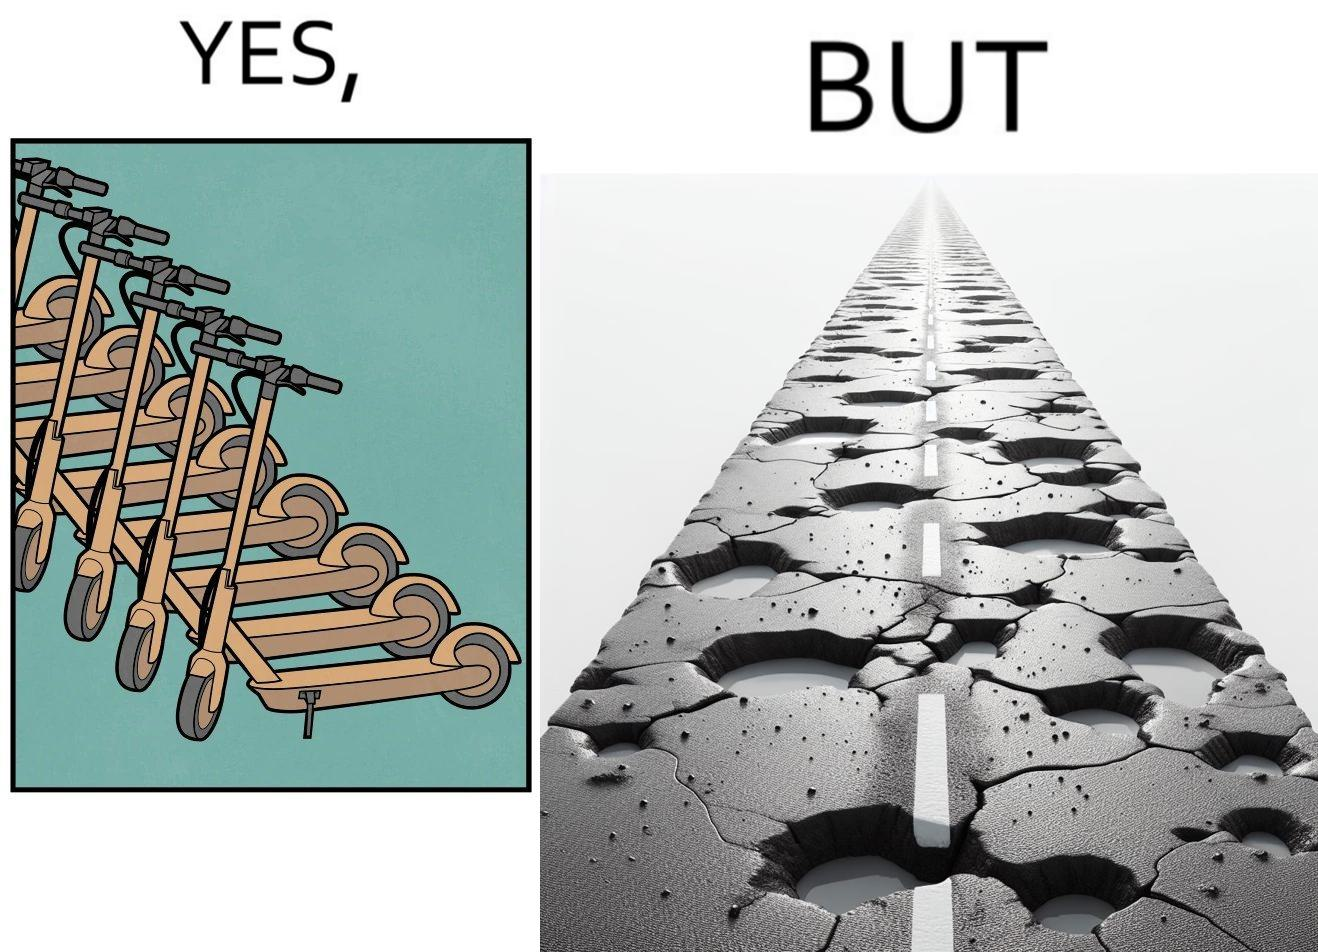Is there satirical content in this image? Yes, this image is satirical. 